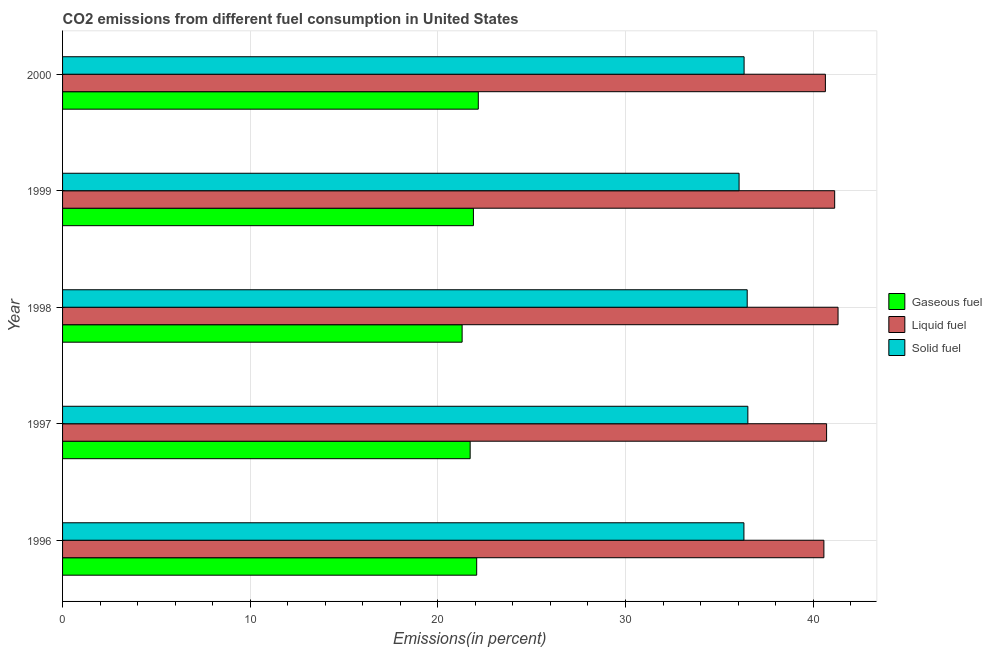How many different coloured bars are there?
Your answer should be very brief. 3. How many groups of bars are there?
Keep it short and to the point. 5. How many bars are there on the 4th tick from the top?
Your answer should be compact. 3. What is the percentage of liquid fuel emission in 2000?
Your answer should be very brief. 40.65. Across all years, what is the maximum percentage of solid fuel emission?
Keep it short and to the point. 36.52. Across all years, what is the minimum percentage of liquid fuel emission?
Offer a terse response. 40.57. In which year was the percentage of liquid fuel emission maximum?
Your answer should be very brief. 1998. In which year was the percentage of liquid fuel emission minimum?
Offer a very short reply. 1996. What is the total percentage of solid fuel emission in the graph?
Offer a terse response. 181.7. What is the difference between the percentage of liquid fuel emission in 1996 and that in 1997?
Your answer should be very brief. -0.14. What is the difference between the percentage of solid fuel emission in 1996 and the percentage of gaseous fuel emission in 1998?
Your answer should be compact. 15.02. What is the average percentage of liquid fuel emission per year?
Your answer should be compact. 40.88. In the year 2000, what is the difference between the percentage of solid fuel emission and percentage of gaseous fuel emission?
Your answer should be very brief. 14.16. In how many years, is the percentage of liquid fuel emission greater than 24 %?
Keep it short and to the point. 5. What is the ratio of the percentage of solid fuel emission in 1999 to that in 2000?
Your response must be concise. 0.99. What is the difference between the highest and the second highest percentage of gaseous fuel emission?
Ensure brevity in your answer.  0.09. What is the difference between the highest and the lowest percentage of gaseous fuel emission?
Provide a short and direct response. 0.86. Is the sum of the percentage of liquid fuel emission in 1996 and 1999 greater than the maximum percentage of gaseous fuel emission across all years?
Your answer should be compact. Yes. What does the 2nd bar from the top in 1997 represents?
Offer a terse response. Liquid fuel. What does the 1st bar from the bottom in 1998 represents?
Make the answer very short. Gaseous fuel. Is it the case that in every year, the sum of the percentage of gaseous fuel emission and percentage of liquid fuel emission is greater than the percentage of solid fuel emission?
Offer a very short reply. Yes. How many years are there in the graph?
Provide a succinct answer. 5. What is the difference between two consecutive major ticks on the X-axis?
Ensure brevity in your answer.  10. Does the graph contain grids?
Your response must be concise. Yes. Where does the legend appear in the graph?
Your answer should be very brief. Center right. How many legend labels are there?
Your response must be concise. 3. How are the legend labels stacked?
Your response must be concise. Vertical. What is the title of the graph?
Ensure brevity in your answer.  CO2 emissions from different fuel consumption in United States. Does "Primary education" appear as one of the legend labels in the graph?
Give a very brief answer. No. What is the label or title of the X-axis?
Your answer should be compact. Emissions(in percent). What is the label or title of the Y-axis?
Your answer should be compact. Year. What is the Emissions(in percent) in Gaseous fuel in 1996?
Keep it short and to the point. 22.07. What is the Emissions(in percent) in Liquid fuel in 1996?
Provide a short and direct response. 40.57. What is the Emissions(in percent) in Solid fuel in 1996?
Provide a succinct answer. 36.31. What is the Emissions(in percent) in Gaseous fuel in 1997?
Provide a short and direct response. 21.72. What is the Emissions(in percent) in Liquid fuel in 1997?
Provide a succinct answer. 40.72. What is the Emissions(in percent) of Solid fuel in 1997?
Provide a short and direct response. 36.52. What is the Emissions(in percent) of Gaseous fuel in 1998?
Offer a very short reply. 21.29. What is the Emissions(in percent) of Liquid fuel in 1998?
Give a very brief answer. 41.33. What is the Emissions(in percent) of Solid fuel in 1998?
Your response must be concise. 36.49. What is the Emissions(in percent) in Gaseous fuel in 1999?
Your response must be concise. 21.9. What is the Emissions(in percent) of Liquid fuel in 1999?
Give a very brief answer. 41.15. What is the Emissions(in percent) of Solid fuel in 1999?
Your answer should be very brief. 36.05. What is the Emissions(in percent) in Gaseous fuel in 2000?
Keep it short and to the point. 22.16. What is the Emissions(in percent) of Liquid fuel in 2000?
Keep it short and to the point. 40.65. What is the Emissions(in percent) in Solid fuel in 2000?
Provide a short and direct response. 36.32. Across all years, what is the maximum Emissions(in percent) in Gaseous fuel?
Make the answer very short. 22.16. Across all years, what is the maximum Emissions(in percent) in Liquid fuel?
Keep it short and to the point. 41.33. Across all years, what is the maximum Emissions(in percent) in Solid fuel?
Your answer should be compact. 36.52. Across all years, what is the minimum Emissions(in percent) in Gaseous fuel?
Provide a short and direct response. 21.29. Across all years, what is the minimum Emissions(in percent) of Liquid fuel?
Provide a short and direct response. 40.57. Across all years, what is the minimum Emissions(in percent) in Solid fuel?
Provide a succinct answer. 36.05. What is the total Emissions(in percent) of Gaseous fuel in the graph?
Offer a very short reply. 109.14. What is the total Emissions(in percent) in Liquid fuel in the graph?
Your answer should be compact. 204.42. What is the total Emissions(in percent) of Solid fuel in the graph?
Your answer should be very brief. 181.7. What is the difference between the Emissions(in percent) in Gaseous fuel in 1996 and that in 1997?
Keep it short and to the point. 0.35. What is the difference between the Emissions(in percent) of Liquid fuel in 1996 and that in 1997?
Ensure brevity in your answer.  -0.14. What is the difference between the Emissions(in percent) of Solid fuel in 1996 and that in 1997?
Provide a short and direct response. -0.21. What is the difference between the Emissions(in percent) of Gaseous fuel in 1996 and that in 1998?
Your response must be concise. 0.78. What is the difference between the Emissions(in percent) of Liquid fuel in 1996 and that in 1998?
Provide a succinct answer. -0.75. What is the difference between the Emissions(in percent) in Solid fuel in 1996 and that in 1998?
Your answer should be compact. -0.18. What is the difference between the Emissions(in percent) of Gaseous fuel in 1996 and that in 1999?
Your answer should be very brief. 0.17. What is the difference between the Emissions(in percent) of Liquid fuel in 1996 and that in 1999?
Ensure brevity in your answer.  -0.57. What is the difference between the Emissions(in percent) of Solid fuel in 1996 and that in 1999?
Give a very brief answer. 0.26. What is the difference between the Emissions(in percent) in Gaseous fuel in 1996 and that in 2000?
Your response must be concise. -0.09. What is the difference between the Emissions(in percent) in Liquid fuel in 1996 and that in 2000?
Offer a terse response. -0.08. What is the difference between the Emissions(in percent) of Solid fuel in 1996 and that in 2000?
Your answer should be very brief. -0.01. What is the difference between the Emissions(in percent) in Gaseous fuel in 1997 and that in 1998?
Your answer should be very brief. 0.43. What is the difference between the Emissions(in percent) in Liquid fuel in 1997 and that in 1998?
Offer a very short reply. -0.61. What is the difference between the Emissions(in percent) of Solid fuel in 1997 and that in 1998?
Provide a succinct answer. 0.04. What is the difference between the Emissions(in percent) of Gaseous fuel in 1997 and that in 1999?
Ensure brevity in your answer.  -0.17. What is the difference between the Emissions(in percent) of Liquid fuel in 1997 and that in 1999?
Make the answer very short. -0.43. What is the difference between the Emissions(in percent) of Solid fuel in 1997 and that in 1999?
Your response must be concise. 0.47. What is the difference between the Emissions(in percent) of Gaseous fuel in 1997 and that in 2000?
Give a very brief answer. -0.43. What is the difference between the Emissions(in percent) of Liquid fuel in 1997 and that in 2000?
Your response must be concise. 0.06. What is the difference between the Emissions(in percent) of Solid fuel in 1997 and that in 2000?
Keep it short and to the point. 0.2. What is the difference between the Emissions(in percent) of Gaseous fuel in 1998 and that in 1999?
Your answer should be compact. -0.6. What is the difference between the Emissions(in percent) in Liquid fuel in 1998 and that in 1999?
Offer a very short reply. 0.18. What is the difference between the Emissions(in percent) in Solid fuel in 1998 and that in 1999?
Make the answer very short. 0.43. What is the difference between the Emissions(in percent) in Gaseous fuel in 1998 and that in 2000?
Offer a terse response. -0.86. What is the difference between the Emissions(in percent) in Liquid fuel in 1998 and that in 2000?
Provide a short and direct response. 0.67. What is the difference between the Emissions(in percent) in Solid fuel in 1998 and that in 2000?
Provide a short and direct response. 0.17. What is the difference between the Emissions(in percent) of Gaseous fuel in 1999 and that in 2000?
Provide a succinct answer. -0.26. What is the difference between the Emissions(in percent) in Liquid fuel in 1999 and that in 2000?
Offer a terse response. 0.49. What is the difference between the Emissions(in percent) in Solid fuel in 1999 and that in 2000?
Provide a succinct answer. -0.27. What is the difference between the Emissions(in percent) in Gaseous fuel in 1996 and the Emissions(in percent) in Liquid fuel in 1997?
Provide a succinct answer. -18.65. What is the difference between the Emissions(in percent) in Gaseous fuel in 1996 and the Emissions(in percent) in Solid fuel in 1997?
Provide a short and direct response. -14.45. What is the difference between the Emissions(in percent) in Liquid fuel in 1996 and the Emissions(in percent) in Solid fuel in 1997?
Provide a succinct answer. 4.05. What is the difference between the Emissions(in percent) in Gaseous fuel in 1996 and the Emissions(in percent) in Liquid fuel in 1998?
Offer a terse response. -19.26. What is the difference between the Emissions(in percent) in Gaseous fuel in 1996 and the Emissions(in percent) in Solid fuel in 1998?
Keep it short and to the point. -14.42. What is the difference between the Emissions(in percent) in Liquid fuel in 1996 and the Emissions(in percent) in Solid fuel in 1998?
Keep it short and to the point. 4.09. What is the difference between the Emissions(in percent) of Gaseous fuel in 1996 and the Emissions(in percent) of Liquid fuel in 1999?
Provide a short and direct response. -19.08. What is the difference between the Emissions(in percent) of Gaseous fuel in 1996 and the Emissions(in percent) of Solid fuel in 1999?
Your response must be concise. -13.98. What is the difference between the Emissions(in percent) in Liquid fuel in 1996 and the Emissions(in percent) in Solid fuel in 1999?
Provide a short and direct response. 4.52. What is the difference between the Emissions(in percent) in Gaseous fuel in 1996 and the Emissions(in percent) in Liquid fuel in 2000?
Make the answer very short. -18.58. What is the difference between the Emissions(in percent) of Gaseous fuel in 1996 and the Emissions(in percent) of Solid fuel in 2000?
Make the answer very short. -14.25. What is the difference between the Emissions(in percent) in Liquid fuel in 1996 and the Emissions(in percent) in Solid fuel in 2000?
Make the answer very short. 4.25. What is the difference between the Emissions(in percent) of Gaseous fuel in 1997 and the Emissions(in percent) of Liquid fuel in 1998?
Your answer should be very brief. -19.61. What is the difference between the Emissions(in percent) of Gaseous fuel in 1997 and the Emissions(in percent) of Solid fuel in 1998?
Your response must be concise. -14.76. What is the difference between the Emissions(in percent) of Liquid fuel in 1997 and the Emissions(in percent) of Solid fuel in 1998?
Make the answer very short. 4.23. What is the difference between the Emissions(in percent) in Gaseous fuel in 1997 and the Emissions(in percent) in Liquid fuel in 1999?
Make the answer very short. -19.43. What is the difference between the Emissions(in percent) of Gaseous fuel in 1997 and the Emissions(in percent) of Solid fuel in 1999?
Make the answer very short. -14.33. What is the difference between the Emissions(in percent) of Liquid fuel in 1997 and the Emissions(in percent) of Solid fuel in 1999?
Keep it short and to the point. 4.66. What is the difference between the Emissions(in percent) in Gaseous fuel in 1997 and the Emissions(in percent) in Liquid fuel in 2000?
Provide a succinct answer. -18.93. What is the difference between the Emissions(in percent) of Gaseous fuel in 1997 and the Emissions(in percent) of Solid fuel in 2000?
Keep it short and to the point. -14.6. What is the difference between the Emissions(in percent) in Liquid fuel in 1997 and the Emissions(in percent) in Solid fuel in 2000?
Offer a terse response. 4.4. What is the difference between the Emissions(in percent) in Gaseous fuel in 1998 and the Emissions(in percent) in Liquid fuel in 1999?
Provide a short and direct response. -19.85. What is the difference between the Emissions(in percent) in Gaseous fuel in 1998 and the Emissions(in percent) in Solid fuel in 1999?
Ensure brevity in your answer.  -14.76. What is the difference between the Emissions(in percent) in Liquid fuel in 1998 and the Emissions(in percent) in Solid fuel in 1999?
Give a very brief answer. 5.27. What is the difference between the Emissions(in percent) of Gaseous fuel in 1998 and the Emissions(in percent) of Liquid fuel in 2000?
Provide a short and direct response. -19.36. What is the difference between the Emissions(in percent) in Gaseous fuel in 1998 and the Emissions(in percent) in Solid fuel in 2000?
Your answer should be very brief. -15.03. What is the difference between the Emissions(in percent) in Liquid fuel in 1998 and the Emissions(in percent) in Solid fuel in 2000?
Ensure brevity in your answer.  5.01. What is the difference between the Emissions(in percent) in Gaseous fuel in 1999 and the Emissions(in percent) in Liquid fuel in 2000?
Keep it short and to the point. -18.76. What is the difference between the Emissions(in percent) of Gaseous fuel in 1999 and the Emissions(in percent) of Solid fuel in 2000?
Offer a very short reply. -14.43. What is the difference between the Emissions(in percent) in Liquid fuel in 1999 and the Emissions(in percent) in Solid fuel in 2000?
Your answer should be compact. 4.83. What is the average Emissions(in percent) in Gaseous fuel per year?
Offer a very short reply. 21.83. What is the average Emissions(in percent) of Liquid fuel per year?
Offer a very short reply. 40.88. What is the average Emissions(in percent) in Solid fuel per year?
Give a very brief answer. 36.34. In the year 1996, what is the difference between the Emissions(in percent) in Gaseous fuel and Emissions(in percent) in Liquid fuel?
Keep it short and to the point. -18.5. In the year 1996, what is the difference between the Emissions(in percent) in Gaseous fuel and Emissions(in percent) in Solid fuel?
Provide a short and direct response. -14.24. In the year 1996, what is the difference between the Emissions(in percent) in Liquid fuel and Emissions(in percent) in Solid fuel?
Provide a short and direct response. 4.26. In the year 1997, what is the difference between the Emissions(in percent) in Gaseous fuel and Emissions(in percent) in Liquid fuel?
Your response must be concise. -19. In the year 1997, what is the difference between the Emissions(in percent) in Gaseous fuel and Emissions(in percent) in Solid fuel?
Make the answer very short. -14.8. In the year 1997, what is the difference between the Emissions(in percent) in Liquid fuel and Emissions(in percent) in Solid fuel?
Provide a short and direct response. 4.2. In the year 1998, what is the difference between the Emissions(in percent) in Gaseous fuel and Emissions(in percent) in Liquid fuel?
Your answer should be compact. -20.03. In the year 1998, what is the difference between the Emissions(in percent) in Gaseous fuel and Emissions(in percent) in Solid fuel?
Keep it short and to the point. -15.19. In the year 1998, what is the difference between the Emissions(in percent) in Liquid fuel and Emissions(in percent) in Solid fuel?
Your answer should be compact. 4.84. In the year 1999, what is the difference between the Emissions(in percent) of Gaseous fuel and Emissions(in percent) of Liquid fuel?
Give a very brief answer. -19.25. In the year 1999, what is the difference between the Emissions(in percent) in Gaseous fuel and Emissions(in percent) in Solid fuel?
Ensure brevity in your answer.  -14.16. In the year 1999, what is the difference between the Emissions(in percent) in Liquid fuel and Emissions(in percent) in Solid fuel?
Give a very brief answer. 5.09. In the year 2000, what is the difference between the Emissions(in percent) of Gaseous fuel and Emissions(in percent) of Liquid fuel?
Offer a very short reply. -18.5. In the year 2000, what is the difference between the Emissions(in percent) of Gaseous fuel and Emissions(in percent) of Solid fuel?
Ensure brevity in your answer.  -14.17. In the year 2000, what is the difference between the Emissions(in percent) of Liquid fuel and Emissions(in percent) of Solid fuel?
Your response must be concise. 4.33. What is the ratio of the Emissions(in percent) in Gaseous fuel in 1996 to that in 1997?
Offer a very short reply. 1.02. What is the ratio of the Emissions(in percent) of Liquid fuel in 1996 to that in 1997?
Offer a very short reply. 1. What is the ratio of the Emissions(in percent) of Gaseous fuel in 1996 to that in 1998?
Make the answer very short. 1.04. What is the ratio of the Emissions(in percent) in Liquid fuel in 1996 to that in 1998?
Provide a succinct answer. 0.98. What is the ratio of the Emissions(in percent) of Gaseous fuel in 1996 to that in 1999?
Ensure brevity in your answer.  1.01. What is the ratio of the Emissions(in percent) in Solid fuel in 1996 to that in 2000?
Your answer should be very brief. 1. What is the ratio of the Emissions(in percent) of Gaseous fuel in 1997 to that in 1998?
Your answer should be very brief. 1.02. What is the ratio of the Emissions(in percent) in Liquid fuel in 1997 to that in 1998?
Offer a terse response. 0.99. What is the ratio of the Emissions(in percent) in Solid fuel in 1997 to that in 1998?
Make the answer very short. 1. What is the ratio of the Emissions(in percent) of Gaseous fuel in 1997 to that in 1999?
Your answer should be compact. 0.99. What is the ratio of the Emissions(in percent) in Solid fuel in 1997 to that in 1999?
Give a very brief answer. 1.01. What is the ratio of the Emissions(in percent) of Gaseous fuel in 1997 to that in 2000?
Keep it short and to the point. 0.98. What is the ratio of the Emissions(in percent) of Liquid fuel in 1997 to that in 2000?
Ensure brevity in your answer.  1. What is the ratio of the Emissions(in percent) in Solid fuel in 1997 to that in 2000?
Your answer should be very brief. 1.01. What is the ratio of the Emissions(in percent) in Gaseous fuel in 1998 to that in 1999?
Give a very brief answer. 0.97. What is the ratio of the Emissions(in percent) of Solid fuel in 1998 to that in 1999?
Provide a short and direct response. 1.01. What is the ratio of the Emissions(in percent) in Gaseous fuel in 1998 to that in 2000?
Make the answer very short. 0.96. What is the ratio of the Emissions(in percent) of Liquid fuel in 1998 to that in 2000?
Offer a very short reply. 1.02. What is the ratio of the Emissions(in percent) of Gaseous fuel in 1999 to that in 2000?
Keep it short and to the point. 0.99. What is the ratio of the Emissions(in percent) in Liquid fuel in 1999 to that in 2000?
Offer a very short reply. 1.01. What is the ratio of the Emissions(in percent) in Solid fuel in 1999 to that in 2000?
Keep it short and to the point. 0.99. What is the difference between the highest and the second highest Emissions(in percent) of Gaseous fuel?
Make the answer very short. 0.09. What is the difference between the highest and the second highest Emissions(in percent) of Liquid fuel?
Your answer should be very brief. 0.18. What is the difference between the highest and the second highest Emissions(in percent) of Solid fuel?
Make the answer very short. 0.04. What is the difference between the highest and the lowest Emissions(in percent) of Gaseous fuel?
Your response must be concise. 0.86. What is the difference between the highest and the lowest Emissions(in percent) in Liquid fuel?
Ensure brevity in your answer.  0.75. What is the difference between the highest and the lowest Emissions(in percent) of Solid fuel?
Make the answer very short. 0.47. 